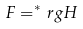<formula> <loc_0><loc_0><loc_500><loc_500>F = ^ { * } _ { \ } r g H</formula> 